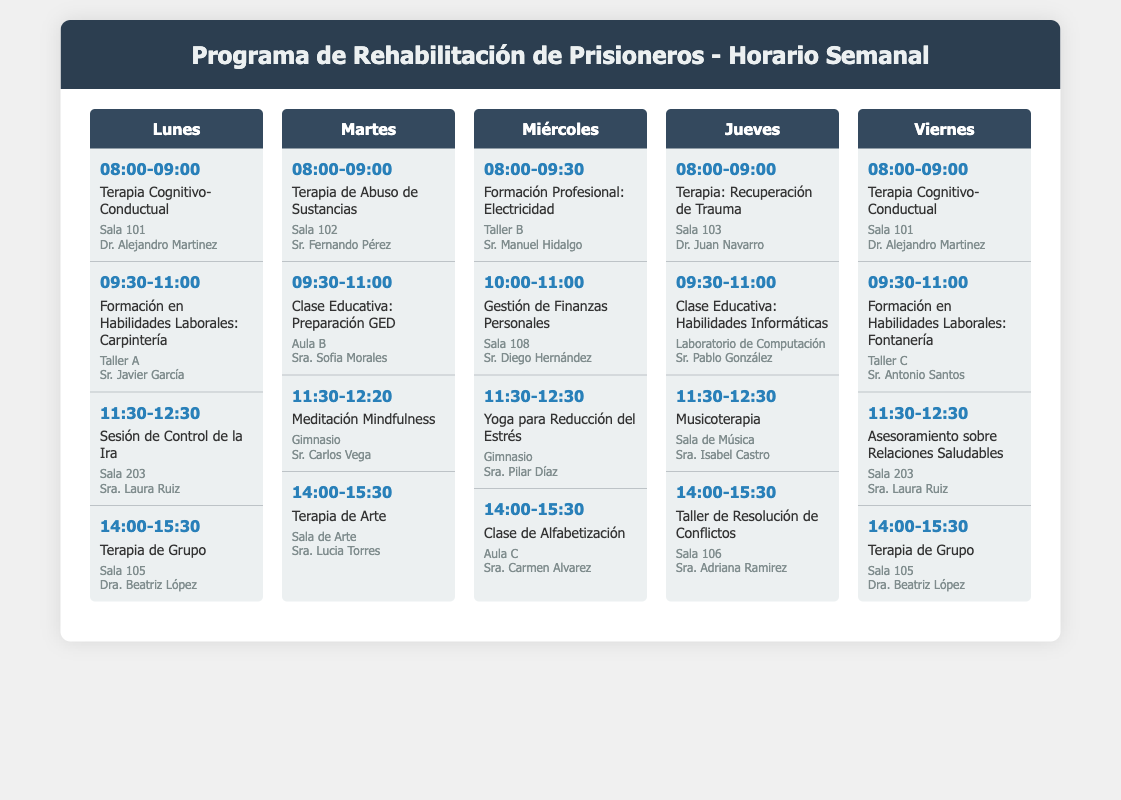¿Cuál es el nombre del facilitador de la terapia cognitivo-conductual? El nombre del facilitador se encuentra al lado de la actividad de terapia cognitivo-conductual en la tabla, que es el Dr. Alejandro Martinez.
Answer: Dr. Alejandro Martinez ¿Qué día se lleva a cabo la clase de alfabetización? La clase de alfabetización está programada para el miércoles, según la estructura del horario.
Answer: Miércoles ¿Cuál es la ubicación de la sesión de control de la ira? La sesión de control de la ira se lleva a cabo en Sala 203, como se indica en el horario.
Answer: Sala 203 ¿Cuántas actividades hay programadas para el jueves? Se cuentan las actividades listadas para el jueves, totalizando cuatro actividades en el horario.
Answer: 4 ¿Qué tipo de terapia se ofrece el martes a las 8:00? Reflejado en el horario, el tipo de terapia ofrecida a esa hora es la terapia de abuso de sustancias.
Answer: Terapia de Abuso de Sustancias ¿Quién facilita la clase sobre habilidades informáticas? El facilitador de la clase sobre habilidades informáticas es el Sr. Pablo González, como se detalla en el horario.
Answer: Sr. Pablo González ¿Qué actividad se lleva a cabo a las 14:00 el viernes? A esa hora, se realizará la terapia de grupo, según el horario semanal.
Answer: Terapia de Grupo ¿Qué día tiene un taller de resolución de conflictos? El taller de resolución de conflictos está programado para el jueves, conforme al calendario.
Answer: Jueves 